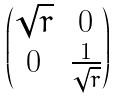<formula> <loc_0><loc_0><loc_500><loc_500>\begin{pmatrix} \sqrt { r } & 0 \\ 0 & \frac { 1 } { \sqrt { r } } \end{pmatrix}</formula> 